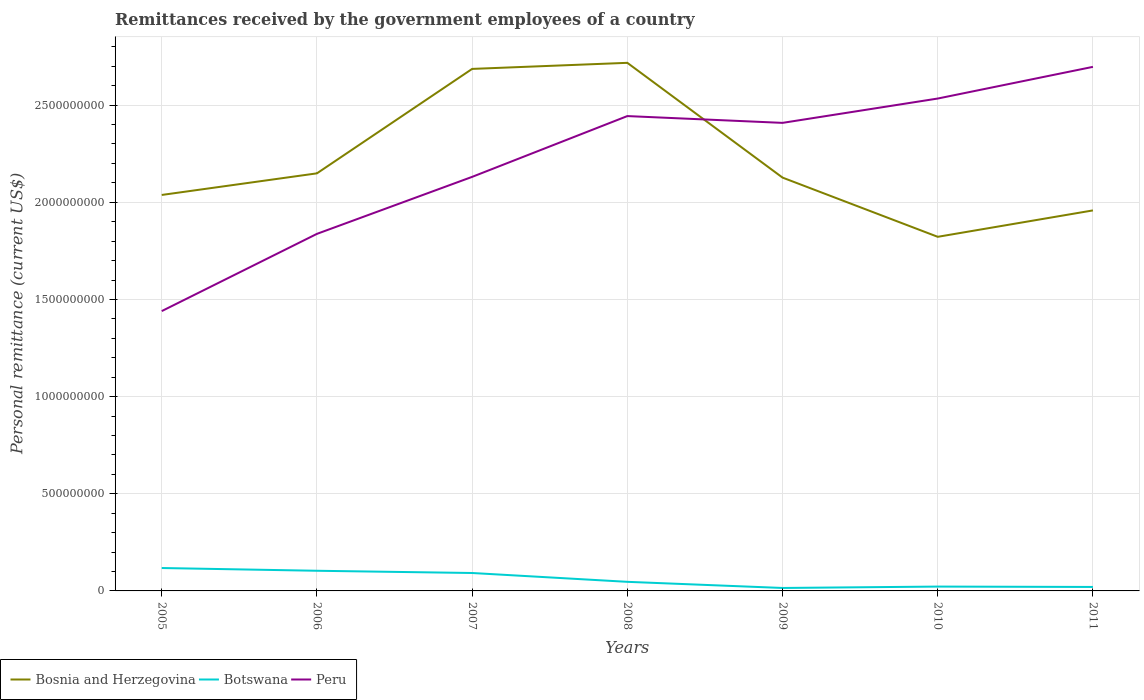How many different coloured lines are there?
Make the answer very short. 3. Across all years, what is the maximum remittances received by the government employees in Botswana?
Offer a terse response. 1.52e+07. In which year was the remittances received by the government employees in Bosnia and Herzegovina maximum?
Your answer should be very brief. 2010. What is the total remittances received by the government employees in Peru in the graph?
Your answer should be compact. -4.03e+08. What is the difference between the highest and the second highest remittances received by the government employees in Peru?
Provide a succinct answer. 1.26e+09. What is the difference between the highest and the lowest remittances received by the government employees in Botswana?
Your response must be concise. 3. How many lines are there?
Keep it short and to the point. 3. How many years are there in the graph?
Offer a very short reply. 7. Are the values on the major ticks of Y-axis written in scientific E-notation?
Provide a succinct answer. No. Does the graph contain grids?
Your response must be concise. Yes. Where does the legend appear in the graph?
Provide a succinct answer. Bottom left. How many legend labels are there?
Your answer should be compact. 3. How are the legend labels stacked?
Give a very brief answer. Horizontal. What is the title of the graph?
Offer a terse response. Remittances received by the government employees of a country. Does "Cuba" appear as one of the legend labels in the graph?
Your answer should be very brief. No. What is the label or title of the Y-axis?
Provide a short and direct response. Personal remittance (current US$). What is the Personal remittance (current US$) in Bosnia and Herzegovina in 2005?
Provide a short and direct response. 2.04e+09. What is the Personal remittance (current US$) of Botswana in 2005?
Offer a terse response. 1.18e+08. What is the Personal remittance (current US$) in Peru in 2005?
Make the answer very short. 1.44e+09. What is the Personal remittance (current US$) in Bosnia and Herzegovina in 2006?
Provide a short and direct response. 2.15e+09. What is the Personal remittance (current US$) of Botswana in 2006?
Keep it short and to the point. 1.04e+08. What is the Personal remittance (current US$) of Peru in 2006?
Your response must be concise. 1.84e+09. What is the Personal remittance (current US$) in Bosnia and Herzegovina in 2007?
Your answer should be compact. 2.69e+09. What is the Personal remittance (current US$) in Botswana in 2007?
Your answer should be very brief. 9.22e+07. What is the Personal remittance (current US$) in Peru in 2007?
Offer a terse response. 2.13e+09. What is the Personal remittance (current US$) of Bosnia and Herzegovina in 2008?
Provide a short and direct response. 2.72e+09. What is the Personal remittance (current US$) in Botswana in 2008?
Give a very brief answer. 4.68e+07. What is the Personal remittance (current US$) of Peru in 2008?
Ensure brevity in your answer.  2.44e+09. What is the Personal remittance (current US$) in Bosnia and Herzegovina in 2009?
Ensure brevity in your answer.  2.13e+09. What is the Personal remittance (current US$) in Botswana in 2009?
Provide a succinct answer. 1.52e+07. What is the Personal remittance (current US$) in Peru in 2009?
Give a very brief answer. 2.41e+09. What is the Personal remittance (current US$) in Bosnia and Herzegovina in 2010?
Your answer should be very brief. 1.82e+09. What is the Personal remittance (current US$) in Botswana in 2010?
Keep it short and to the point. 2.23e+07. What is the Personal remittance (current US$) in Peru in 2010?
Offer a terse response. 2.53e+09. What is the Personal remittance (current US$) of Bosnia and Herzegovina in 2011?
Your answer should be very brief. 1.96e+09. What is the Personal remittance (current US$) of Botswana in 2011?
Your answer should be very brief. 2.04e+07. What is the Personal remittance (current US$) in Peru in 2011?
Offer a very short reply. 2.70e+09. Across all years, what is the maximum Personal remittance (current US$) of Bosnia and Herzegovina?
Offer a terse response. 2.72e+09. Across all years, what is the maximum Personal remittance (current US$) in Botswana?
Your response must be concise. 1.18e+08. Across all years, what is the maximum Personal remittance (current US$) in Peru?
Provide a succinct answer. 2.70e+09. Across all years, what is the minimum Personal remittance (current US$) of Bosnia and Herzegovina?
Provide a short and direct response. 1.82e+09. Across all years, what is the minimum Personal remittance (current US$) in Botswana?
Provide a short and direct response. 1.52e+07. Across all years, what is the minimum Personal remittance (current US$) of Peru?
Your answer should be very brief. 1.44e+09. What is the total Personal remittance (current US$) in Bosnia and Herzegovina in the graph?
Make the answer very short. 1.55e+1. What is the total Personal remittance (current US$) in Botswana in the graph?
Ensure brevity in your answer.  4.19e+08. What is the total Personal remittance (current US$) of Peru in the graph?
Provide a succinct answer. 1.55e+1. What is the difference between the Personal remittance (current US$) of Bosnia and Herzegovina in 2005 and that in 2006?
Give a very brief answer. -1.11e+08. What is the difference between the Personal remittance (current US$) in Botswana in 2005 and that in 2006?
Ensure brevity in your answer.  1.41e+07. What is the difference between the Personal remittance (current US$) in Peru in 2005 and that in 2006?
Your answer should be very brief. -3.97e+08. What is the difference between the Personal remittance (current US$) of Bosnia and Herzegovina in 2005 and that in 2007?
Your answer should be very brief. -6.49e+08. What is the difference between the Personal remittance (current US$) in Botswana in 2005 and that in 2007?
Make the answer very short. 2.57e+07. What is the difference between the Personal remittance (current US$) of Peru in 2005 and that in 2007?
Offer a terse response. -6.91e+08. What is the difference between the Personal remittance (current US$) of Bosnia and Herzegovina in 2005 and that in 2008?
Provide a succinct answer. -6.80e+08. What is the difference between the Personal remittance (current US$) of Botswana in 2005 and that in 2008?
Your answer should be very brief. 7.11e+07. What is the difference between the Personal remittance (current US$) in Peru in 2005 and that in 2008?
Provide a short and direct response. -1.00e+09. What is the difference between the Personal remittance (current US$) of Bosnia and Herzegovina in 2005 and that in 2009?
Give a very brief answer. -8.93e+07. What is the difference between the Personal remittance (current US$) of Botswana in 2005 and that in 2009?
Your answer should be compact. 1.03e+08. What is the difference between the Personal remittance (current US$) of Peru in 2005 and that in 2009?
Make the answer very short. -9.69e+08. What is the difference between the Personal remittance (current US$) in Bosnia and Herzegovina in 2005 and that in 2010?
Your response must be concise. 2.15e+08. What is the difference between the Personal remittance (current US$) of Botswana in 2005 and that in 2010?
Provide a short and direct response. 9.56e+07. What is the difference between the Personal remittance (current US$) of Peru in 2005 and that in 2010?
Give a very brief answer. -1.09e+09. What is the difference between the Personal remittance (current US$) in Bosnia and Herzegovina in 2005 and that in 2011?
Keep it short and to the point. 7.95e+07. What is the difference between the Personal remittance (current US$) of Botswana in 2005 and that in 2011?
Give a very brief answer. 9.75e+07. What is the difference between the Personal remittance (current US$) in Peru in 2005 and that in 2011?
Offer a very short reply. -1.26e+09. What is the difference between the Personal remittance (current US$) in Bosnia and Herzegovina in 2006 and that in 2007?
Your response must be concise. -5.37e+08. What is the difference between the Personal remittance (current US$) in Botswana in 2006 and that in 2007?
Provide a short and direct response. 1.15e+07. What is the difference between the Personal remittance (current US$) of Peru in 2006 and that in 2007?
Your answer should be very brief. -2.93e+08. What is the difference between the Personal remittance (current US$) in Bosnia and Herzegovina in 2006 and that in 2008?
Provide a short and direct response. -5.69e+08. What is the difference between the Personal remittance (current US$) in Botswana in 2006 and that in 2008?
Give a very brief answer. 5.69e+07. What is the difference between the Personal remittance (current US$) of Peru in 2006 and that in 2008?
Keep it short and to the point. -6.06e+08. What is the difference between the Personal remittance (current US$) of Bosnia and Herzegovina in 2006 and that in 2009?
Keep it short and to the point. 2.19e+07. What is the difference between the Personal remittance (current US$) in Botswana in 2006 and that in 2009?
Keep it short and to the point. 8.85e+07. What is the difference between the Personal remittance (current US$) of Peru in 2006 and that in 2009?
Give a very brief answer. -5.71e+08. What is the difference between the Personal remittance (current US$) in Bosnia and Herzegovina in 2006 and that in 2010?
Your response must be concise. 3.27e+08. What is the difference between the Personal remittance (current US$) in Botswana in 2006 and that in 2010?
Ensure brevity in your answer.  8.14e+07. What is the difference between the Personal remittance (current US$) of Peru in 2006 and that in 2010?
Give a very brief answer. -6.96e+08. What is the difference between the Personal remittance (current US$) in Bosnia and Herzegovina in 2006 and that in 2011?
Offer a terse response. 1.91e+08. What is the difference between the Personal remittance (current US$) of Botswana in 2006 and that in 2011?
Your response must be concise. 8.33e+07. What is the difference between the Personal remittance (current US$) in Peru in 2006 and that in 2011?
Keep it short and to the point. -8.59e+08. What is the difference between the Personal remittance (current US$) of Bosnia and Herzegovina in 2007 and that in 2008?
Provide a succinct answer. -3.12e+07. What is the difference between the Personal remittance (current US$) in Botswana in 2007 and that in 2008?
Your answer should be very brief. 4.54e+07. What is the difference between the Personal remittance (current US$) in Peru in 2007 and that in 2008?
Keep it short and to the point. -3.13e+08. What is the difference between the Personal remittance (current US$) of Bosnia and Herzegovina in 2007 and that in 2009?
Give a very brief answer. 5.59e+08. What is the difference between the Personal remittance (current US$) in Botswana in 2007 and that in 2009?
Make the answer very short. 7.70e+07. What is the difference between the Personal remittance (current US$) in Peru in 2007 and that in 2009?
Provide a short and direct response. -2.78e+08. What is the difference between the Personal remittance (current US$) of Bosnia and Herzegovina in 2007 and that in 2010?
Your answer should be very brief. 8.64e+08. What is the difference between the Personal remittance (current US$) of Botswana in 2007 and that in 2010?
Offer a terse response. 6.99e+07. What is the difference between the Personal remittance (current US$) of Peru in 2007 and that in 2010?
Provide a succinct answer. -4.03e+08. What is the difference between the Personal remittance (current US$) of Bosnia and Herzegovina in 2007 and that in 2011?
Provide a short and direct response. 7.28e+08. What is the difference between the Personal remittance (current US$) of Botswana in 2007 and that in 2011?
Offer a very short reply. 7.18e+07. What is the difference between the Personal remittance (current US$) in Peru in 2007 and that in 2011?
Offer a very short reply. -5.66e+08. What is the difference between the Personal remittance (current US$) in Bosnia and Herzegovina in 2008 and that in 2009?
Keep it short and to the point. 5.91e+08. What is the difference between the Personal remittance (current US$) of Botswana in 2008 and that in 2009?
Give a very brief answer. 3.16e+07. What is the difference between the Personal remittance (current US$) of Peru in 2008 and that in 2009?
Ensure brevity in your answer.  3.49e+07. What is the difference between the Personal remittance (current US$) of Bosnia and Herzegovina in 2008 and that in 2010?
Keep it short and to the point. 8.95e+08. What is the difference between the Personal remittance (current US$) in Botswana in 2008 and that in 2010?
Ensure brevity in your answer.  2.45e+07. What is the difference between the Personal remittance (current US$) in Peru in 2008 and that in 2010?
Your answer should be very brief. -9.03e+07. What is the difference between the Personal remittance (current US$) of Bosnia and Herzegovina in 2008 and that in 2011?
Make the answer very short. 7.59e+08. What is the difference between the Personal remittance (current US$) in Botswana in 2008 and that in 2011?
Offer a very short reply. 2.64e+07. What is the difference between the Personal remittance (current US$) in Peru in 2008 and that in 2011?
Offer a terse response. -2.53e+08. What is the difference between the Personal remittance (current US$) in Bosnia and Herzegovina in 2009 and that in 2010?
Your answer should be compact. 3.05e+08. What is the difference between the Personal remittance (current US$) in Botswana in 2009 and that in 2010?
Provide a succinct answer. -7.11e+06. What is the difference between the Personal remittance (current US$) in Peru in 2009 and that in 2010?
Provide a succinct answer. -1.25e+08. What is the difference between the Personal remittance (current US$) of Bosnia and Herzegovina in 2009 and that in 2011?
Ensure brevity in your answer.  1.69e+08. What is the difference between the Personal remittance (current US$) of Botswana in 2009 and that in 2011?
Ensure brevity in your answer.  -5.23e+06. What is the difference between the Personal remittance (current US$) in Peru in 2009 and that in 2011?
Your response must be concise. -2.88e+08. What is the difference between the Personal remittance (current US$) of Bosnia and Herzegovina in 2010 and that in 2011?
Give a very brief answer. -1.36e+08. What is the difference between the Personal remittance (current US$) in Botswana in 2010 and that in 2011?
Ensure brevity in your answer.  1.88e+06. What is the difference between the Personal remittance (current US$) in Peru in 2010 and that in 2011?
Your response must be concise. -1.63e+08. What is the difference between the Personal remittance (current US$) in Bosnia and Herzegovina in 2005 and the Personal remittance (current US$) in Botswana in 2006?
Your answer should be compact. 1.93e+09. What is the difference between the Personal remittance (current US$) of Bosnia and Herzegovina in 2005 and the Personal remittance (current US$) of Peru in 2006?
Provide a succinct answer. 2.00e+08. What is the difference between the Personal remittance (current US$) of Botswana in 2005 and the Personal remittance (current US$) of Peru in 2006?
Make the answer very short. -1.72e+09. What is the difference between the Personal remittance (current US$) in Bosnia and Herzegovina in 2005 and the Personal remittance (current US$) in Botswana in 2007?
Offer a very short reply. 1.95e+09. What is the difference between the Personal remittance (current US$) in Bosnia and Herzegovina in 2005 and the Personal remittance (current US$) in Peru in 2007?
Provide a short and direct response. -9.31e+07. What is the difference between the Personal remittance (current US$) of Botswana in 2005 and the Personal remittance (current US$) of Peru in 2007?
Your response must be concise. -2.01e+09. What is the difference between the Personal remittance (current US$) in Bosnia and Herzegovina in 2005 and the Personal remittance (current US$) in Botswana in 2008?
Offer a very short reply. 1.99e+09. What is the difference between the Personal remittance (current US$) in Bosnia and Herzegovina in 2005 and the Personal remittance (current US$) in Peru in 2008?
Your response must be concise. -4.06e+08. What is the difference between the Personal remittance (current US$) in Botswana in 2005 and the Personal remittance (current US$) in Peru in 2008?
Give a very brief answer. -2.33e+09. What is the difference between the Personal remittance (current US$) of Bosnia and Herzegovina in 2005 and the Personal remittance (current US$) of Botswana in 2009?
Your answer should be compact. 2.02e+09. What is the difference between the Personal remittance (current US$) of Bosnia and Herzegovina in 2005 and the Personal remittance (current US$) of Peru in 2009?
Provide a short and direct response. -3.71e+08. What is the difference between the Personal remittance (current US$) of Botswana in 2005 and the Personal remittance (current US$) of Peru in 2009?
Provide a succinct answer. -2.29e+09. What is the difference between the Personal remittance (current US$) of Bosnia and Herzegovina in 2005 and the Personal remittance (current US$) of Botswana in 2010?
Provide a short and direct response. 2.02e+09. What is the difference between the Personal remittance (current US$) in Bosnia and Herzegovina in 2005 and the Personal remittance (current US$) in Peru in 2010?
Keep it short and to the point. -4.96e+08. What is the difference between the Personal remittance (current US$) of Botswana in 2005 and the Personal remittance (current US$) of Peru in 2010?
Your response must be concise. -2.42e+09. What is the difference between the Personal remittance (current US$) of Bosnia and Herzegovina in 2005 and the Personal remittance (current US$) of Botswana in 2011?
Offer a very short reply. 2.02e+09. What is the difference between the Personal remittance (current US$) of Bosnia and Herzegovina in 2005 and the Personal remittance (current US$) of Peru in 2011?
Your response must be concise. -6.59e+08. What is the difference between the Personal remittance (current US$) of Botswana in 2005 and the Personal remittance (current US$) of Peru in 2011?
Offer a terse response. -2.58e+09. What is the difference between the Personal remittance (current US$) in Bosnia and Herzegovina in 2006 and the Personal remittance (current US$) in Botswana in 2007?
Your answer should be compact. 2.06e+09. What is the difference between the Personal remittance (current US$) in Bosnia and Herzegovina in 2006 and the Personal remittance (current US$) in Peru in 2007?
Make the answer very short. 1.81e+07. What is the difference between the Personal remittance (current US$) in Botswana in 2006 and the Personal remittance (current US$) in Peru in 2007?
Your response must be concise. -2.03e+09. What is the difference between the Personal remittance (current US$) in Bosnia and Herzegovina in 2006 and the Personal remittance (current US$) in Botswana in 2008?
Provide a succinct answer. 2.10e+09. What is the difference between the Personal remittance (current US$) in Bosnia and Herzegovina in 2006 and the Personal remittance (current US$) in Peru in 2008?
Offer a terse response. -2.95e+08. What is the difference between the Personal remittance (current US$) in Botswana in 2006 and the Personal remittance (current US$) in Peru in 2008?
Your answer should be very brief. -2.34e+09. What is the difference between the Personal remittance (current US$) of Bosnia and Herzegovina in 2006 and the Personal remittance (current US$) of Botswana in 2009?
Your response must be concise. 2.13e+09. What is the difference between the Personal remittance (current US$) in Bosnia and Herzegovina in 2006 and the Personal remittance (current US$) in Peru in 2009?
Your response must be concise. -2.60e+08. What is the difference between the Personal remittance (current US$) of Botswana in 2006 and the Personal remittance (current US$) of Peru in 2009?
Offer a very short reply. -2.30e+09. What is the difference between the Personal remittance (current US$) in Bosnia and Herzegovina in 2006 and the Personal remittance (current US$) in Botswana in 2010?
Provide a short and direct response. 2.13e+09. What is the difference between the Personal remittance (current US$) of Bosnia and Herzegovina in 2006 and the Personal remittance (current US$) of Peru in 2010?
Provide a short and direct response. -3.85e+08. What is the difference between the Personal remittance (current US$) of Botswana in 2006 and the Personal remittance (current US$) of Peru in 2010?
Make the answer very short. -2.43e+09. What is the difference between the Personal remittance (current US$) of Bosnia and Herzegovina in 2006 and the Personal remittance (current US$) of Botswana in 2011?
Ensure brevity in your answer.  2.13e+09. What is the difference between the Personal remittance (current US$) of Bosnia and Herzegovina in 2006 and the Personal remittance (current US$) of Peru in 2011?
Provide a succinct answer. -5.48e+08. What is the difference between the Personal remittance (current US$) in Botswana in 2006 and the Personal remittance (current US$) in Peru in 2011?
Offer a very short reply. -2.59e+09. What is the difference between the Personal remittance (current US$) of Bosnia and Herzegovina in 2007 and the Personal remittance (current US$) of Botswana in 2008?
Your response must be concise. 2.64e+09. What is the difference between the Personal remittance (current US$) in Bosnia and Herzegovina in 2007 and the Personal remittance (current US$) in Peru in 2008?
Make the answer very short. 2.43e+08. What is the difference between the Personal remittance (current US$) of Botswana in 2007 and the Personal remittance (current US$) of Peru in 2008?
Your response must be concise. -2.35e+09. What is the difference between the Personal remittance (current US$) in Bosnia and Herzegovina in 2007 and the Personal remittance (current US$) in Botswana in 2009?
Offer a terse response. 2.67e+09. What is the difference between the Personal remittance (current US$) in Bosnia and Herzegovina in 2007 and the Personal remittance (current US$) in Peru in 2009?
Offer a terse response. 2.78e+08. What is the difference between the Personal remittance (current US$) in Botswana in 2007 and the Personal remittance (current US$) in Peru in 2009?
Your answer should be compact. -2.32e+09. What is the difference between the Personal remittance (current US$) in Bosnia and Herzegovina in 2007 and the Personal remittance (current US$) in Botswana in 2010?
Keep it short and to the point. 2.66e+09. What is the difference between the Personal remittance (current US$) of Bosnia and Herzegovina in 2007 and the Personal remittance (current US$) of Peru in 2010?
Give a very brief answer. 1.53e+08. What is the difference between the Personal remittance (current US$) in Botswana in 2007 and the Personal remittance (current US$) in Peru in 2010?
Your answer should be very brief. -2.44e+09. What is the difference between the Personal remittance (current US$) in Bosnia and Herzegovina in 2007 and the Personal remittance (current US$) in Botswana in 2011?
Your response must be concise. 2.67e+09. What is the difference between the Personal remittance (current US$) in Bosnia and Herzegovina in 2007 and the Personal remittance (current US$) in Peru in 2011?
Your answer should be very brief. -1.05e+07. What is the difference between the Personal remittance (current US$) of Botswana in 2007 and the Personal remittance (current US$) of Peru in 2011?
Your answer should be very brief. -2.60e+09. What is the difference between the Personal remittance (current US$) in Bosnia and Herzegovina in 2008 and the Personal remittance (current US$) in Botswana in 2009?
Your answer should be compact. 2.70e+09. What is the difference between the Personal remittance (current US$) of Bosnia and Herzegovina in 2008 and the Personal remittance (current US$) of Peru in 2009?
Make the answer very short. 3.09e+08. What is the difference between the Personal remittance (current US$) in Botswana in 2008 and the Personal remittance (current US$) in Peru in 2009?
Provide a short and direct response. -2.36e+09. What is the difference between the Personal remittance (current US$) of Bosnia and Herzegovina in 2008 and the Personal remittance (current US$) of Botswana in 2010?
Your answer should be very brief. 2.70e+09. What is the difference between the Personal remittance (current US$) in Bosnia and Herzegovina in 2008 and the Personal remittance (current US$) in Peru in 2010?
Your answer should be very brief. 1.84e+08. What is the difference between the Personal remittance (current US$) in Botswana in 2008 and the Personal remittance (current US$) in Peru in 2010?
Offer a terse response. -2.49e+09. What is the difference between the Personal remittance (current US$) of Bosnia and Herzegovina in 2008 and the Personal remittance (current US$) of Botswana in 2011?
Keep it short and to the point. 2.70e+09. What is the difference between the Personal remittance (current US$) in Bosnia and Herzegovina in 2008 and the Personal remittance (current US$) in Peru in 2011?
Keep it short and to the point. 2.07e+07. What is the difference between the Personal remittance (current US$) of Botswana in 2008 and the Personal remittance (current US$) of Peru in 2011?
Give a very brief answer. -2.65e+09. What is the difference between the Personal remittance (current US$) of Bosnia and Herzegovina in 2009 and the Personal remittance (current US$) of Botswana in 2010?
Provide a short and direct response. 2.10e+09. What is the difference between the Personal remittance (current US$) of Bosnia and Herzegovina in 2009 and the Personal remittance (current US$) of Peru in 2010?
Provide a succinct answer. -4.07e+08. What is the difference between the Personal remittance (current US$) of Botswana in 2009 and the Personal remittance (current US$) of Peru in 2010?
Keep it short and to the point. -2.52e+09. What is the difference between the Personal remittance (current US$) of Bosnia and Herzegovina in 2009 and the Personal remittance (current US$) of Botswana in 2011?
Give a very brief answer. 2.11e+09. What is the difference between the Personal remittance (current US$) of Bosnia and Herzegovina in 2009 and the Personal remittance (current US$) of Peru in 2011?
Offer a very short reply. -5.70e+08. What is the difference between the Personal remittance (current US$) in Botswana in 2009 and the Personal remittance (current US$) in Peru in 2011?
Give a very brief answer. -2.68e+09. What is the difference between the Personal remittance (current US$) of Bosnia and Herzegovina in 2010 and the Personal remittance (current US$) of Botswana in 2011?
Give a very brief answer. 1.80e+09. What is the difference between the Personal remittance (current US$) of Bosnia and Herzegovina in 2010 and the Personal remittance (current US$) of Peru in 2011?
Offer a terse response. -8.75e+08. What is the difference between the Personal remittance (current US$) of Botswana in 2010 and the Personal remittance (current US$) of Peru in 2011?
Make the answer very short. -2.67e+09. What is the average Personal remittance (current US$) of Bosnia and Herzegovina per year?
Keep it short and to the point. 2.21e+09. What is the average Personal remittance (current US$) of Botswana per year?
Provide a short and direct response. 5.98e+07. What is the average Personal remittance (current US$) of Peru per year?
Offer a very short reply. 2.21e+09. In the year 2005, what is the difference between the Personal remittance (current US$) in Bosnia and Herzegovina and Personal remittance (current US$) in Botswana?
Provide a succinct answer. 1.92e+09. In the year 2005, what is the difference between the Personal remittance (current US$) in Bosnia and Herzegovina and Personal remittance (current US$) in Peru?
Your response must be concise. 5.98e+08. In the year 2005, what is the difference between the Personal remittance (current US$) in Botswana and Personal remittance (current US$) in Peru?
Provide a short and direct response. -1.32e+09. In the year 2006, what is the difference between the Personal remittance (current US$) in Bosnia and Herzegovina and Personal remittance (current US$) in Botswana?
Offer a very short reply. 2.05e+09. In the year 2006, what is the difference between the Personal remittance (current US$) in Bosnia and Herzegovina and Personal remittance (current US$) in Peru?
Keep it short and to the point. 3.11e+08. In the year 2006, what is the difference between the Personal remittance (current US$) of Botswana and Personal remittance (current US$) of Peru?
Provide a short and direct response. -1.73e+09. In the year 2007, what is the difference between the Personal remittance (current US$) of Bosnia and Herzegovina and Personal remittance (current US$) of Botswana?
Provide a succinct answer. 2.59e+09. In the year 2007, what is the difference between the Personal remittance (current US$) in Bosnia and Herzegovina and Personal remittance (current US$) in Peru?
Provide a succinct answer. 5.56e+08. In the year 2007, what is the difference between the Personal remittance (current US$) in Botswana and Personal remittance (current US$) in Peru?
Your answer should be compact. -2.04e+09. In the year 2008, what is the difference between the Personal remittance (current US$) of Bosnia and Herzegovina and Personal remittance (current US$) of Botswana?
Your response must be concise. 2.67e+09. In the year 2008, what is the difference between the Personal remittance (current US$) of Bosnia and Herzegovina and Personal remittance (current US$) of Peru?
Ensure brevity in your answer.  2.74e+08. In the year 2008, what is the difference between the Personal remittance (current US$) of Botswana and Personal remittance (current US$) of Peru?
Offer a terse response. -2.40e+09. In the year 2009, what is the difference between the Personal remittance (current US$) of Bosnia and Herzegovina and Personal remittance (current US$) of Botswana?
Keep it short and to the point. 2.11e+09. In the year 2009, what is the difference between the Personal remittance (current US$) in Bosnia and Herzegovina and Personal remittance (current US$) in Peru?
Offer a terse response. -2.82e+08. In the year 2009, what is the difference between the Personal remittance (current US$) in Botswana and Personal remittance (current US$) in Peru?
Provide a short and direct response. -2.39e+09. In the year 2010, what is the difference between the Personal remittance (current US$) in Bosnia and Herzegovina and Personal remittance (current US$) in Botswana?
Your response must be concise. 1.80e+09. In the year 2010, what is the difference between the Personal remittance (current US$) in Bosnia and Herzegovina and Personal remittance (current US$) in Peru?
Ensure brevity in your answer.  -7.12e+08. In the year 2010, what is the difference between the Personal remittance (current US$) of Botswana and Personal remittance (current US$) of Peru?
Keep it short and to the point. -2.51e+09. In the year 2011, what is the difference between the Personal remittance (current US$) of Bosnia and Herzegovina and Personal remittance (current US$) of Botswana?
Your answer should be very brief. 1.94e+09. In the year 2011, what is the difference between the Personal remittance (current US$) in Bosnia and Herzegovina and Personal remittance (current US$) in Peru?
Your answer should be very brief. -7.39e+08. In the year 2011, what is the difference between the Personal remittance (current US$) of Botswana and Personal remittance (current US$) of Peru?
Keep it short and to the point. -2.68e+09. What is the ratio of the Personal remittance (current US$) of Bosnia and Herzegovina in 2005 to that in 2006?
Offer a terse response. 0.95. What is the ratio of the Personal remittance (current US$) of Botswana in 2005 to that in 2006?
Make the answer very short. 1.14. What is the ratio of the Personal remittance (current US$) in Peru in 2005 to that in 2006?
Your answer should be very brief. 0.78. What is the ratio of the Personal remittance (current US$) of Bosnia and Herzegovina in 2005 to that in 2007?
Your answer should be very brief. 0.76. What is the ratio of the Personal remittance (current US$) in Botswana in 2005 to that in 2007?
Give a very brief answer. 1.28. What is the ratio of the Personal remittance (current US$) of Peru in 2005 to that in 2007?
Ensure brevity in your answer.  0.68. What is the ratio of the Personal remittance (current US$) of Bosnia and Herzegovina in 2005 to that in 2008?
Keep it short and to the point. 0.75. What is the ratio of the Personal remittance (current US$) in Botswana in 2005 to that in 2008?
Provide a short and direct response. 2.52. What is the ratio of the Personal remittance (current US$) in Peru in 2005 to that in 2008?
Offer a terse response. 0.59. What is the ratio of the Personal remittance (current US$) in Bosnia and Herzegovina in 2005 to that in 2009?
Make the answer very short. 0.96. What is the ratio of the Personal remittance (current US$) in Botswana in 2005 to that in 2009?
Offer a very short reply. 7.75. What is the ratio of the Personal remittance (current US$) in Peru in 2005 to that in 2009?
Make the answer very short. 0.6. What is the ratio of the Personal remittance (current US$) in Bosnia and Herzegovina in 2005 to that in 2010?
Your answer should be very brief. 1.12. What is the ratio of the Personal remittance (current US$) in Botswana in 2005 to that in 2010?
Provide a short and direct response. 5.28. What is the ratio of the Personal remittance (current US$) of Peru in 2005 to that in 2010?
Give a very brief answer. 0.57. What is the ratio of the Personal remittance (current US$) of Bosnia and Herzegovina in 2005 to that in 2011?
Offer a very short reply. 1.04. What is the ratio of the Personal remittance (current US$) in Botswana in 2005 to that in 2011?
Offer a terse response. 5.77. What is the ratio of the Personal remittance (current US$) in Peru in 2005 to that in 2011?
Your response must be concise. 0.53. What is the ratio of the Personal remittance (current US$) in Bosnia and Herzegovina in 2006 to that in 2007?
Your answer should be very brief. 0.8. What is the ratio of the Personal remittance (current US$) in Botswana in 2006 to that in 2007?
Your response must be concise. 1.13. What is the ratio of the Personal remittance (current US$) in Peru in 2006 to that in 2007?
Ensure brevity in your answer.  0.86. What is the ratio of the Personal remittance (current US$) in Bosnia and Herzegovina in 2006 to that in 2008?
Provide a succinct answer. 0.79. What is the ratio of the Personal remittance (current US$) of Botswana in 2006 to that in 2008?
Ensure brevity in your answer.  2.22. What is the ratio of the Personal remittance (current US$) of Peru in 2006 to that in 2008?
Keep it short and to the point. 0.75. What is the ratio of the Personal remittance (current US$) of Bosnia and Herzegovina in 2006 to that in 2009?
Provide a short and direct response. 1.01. What is the ratio of the Personal remittance (current US$) in Botswana in 2006 to that in 2009?
Your answer should be very brief. 6.82. What is the ratio of the Personal remittance (current US$) of Peru in 2006 to that in 2009?
Offer a very short reply. 0.76. What is the ratio of the Personal remittance (current US$) of Bosnia and Herzegovina in 2006 to that in 2010?
Your answer should be very brief. 1.18. What is the ratio of the Personal remittance (current US$) in Botswana in 2006 to that in 2010?
Provide a succinct answer. 4.65. What is the ratio of the Personal remittance (current US$) in Peru in 2006 to that in 2010?
Your response must be concise. 0.73. What is the ratio of the Personal remittance (current US$) in Bosnia and Herzegovina in 2006 to that in 2011?
Offer a very short reply. 1.1. What is the ratio of the Personal remittance (current US$) of Botswana in 2006 to that in 2011?
Your answer should be very brief. 5.08. What is the ratio of the Personal remittance (current US$) of Peru in 2006 to that in 2011?
Provide a succinct answer. 0.68. What is the ratio of the Personal remittance (current US$) in Bosnia and Herzegovina in 2007 to that in 2008?
Ensure brevity in your answer.  0.99. What is the ratio of the Personal remittance (current US$) of Botswana in 2007 to that in 2008?
Keep it short and to the point. 1.97. What is the ratio of the Personal remittance (current US$) of Peru in 2007 to that in 2008?
Your answer should be very brief. 0.87. What is the ratio of the Personal remittance (current US$) of Bosnia and Herzegovina in 2007 to that in 2009?
Offer a very short reply. 1.26. What is the ratio of the Personal remittance (current US$) in Botswana in 2007 to that in 2009?
Ensure brevity in your answer.  6.06. What is the ratio of the Personal remittance (current US$) of Peru in 2007 to that in 2009?
Offer a very short reply. 0.88. What is the ratio of the Personal remittance (current US$) of Bosnia and Herzegovina in 2007 to that in 2010?
Your answer should be compact. 1.47. What is the ratio of the Personal remittance (current US$) of Botswana in 2007 to that in 2010?
Ensure brevity in your answer.  4.13. What is the ratio of the Personal remittance (current US$) in Peru in 2007 to that in 2010?
Your answer should be very brief. 0.84. What is the ratio of the Personal remittance (current US$) of Bosnia and Herzegovina in 2007 to that in 2011?
Give a very brief answer. 1.37. What is the ratio of the Personal remittance (current US$) in Botswana in 2007 to that in 2011?
Your answer should be compact. 4.51. What is the ratio of the Personal remittance (current US$) in Peru in 2007 to that in 2011?
Provide a short and direct response. 0.79. What is the ratio of the Personal remittance (current US$) of Bosnia and Herzegovina in 2008 to that in 2009?
Keep it short and to the point. 1.28. What is the ratio of the Personal remittance (current US$) in Botswana in 2008 to that in 2009?
Your response must be concise. 3.08. What is the ratio of the Personal remittance (current US$) of Peru in 2008 to that in 2009?
Keep it short and to the point. 1.01. What is the ratio of the Personal remittance (current US$) of Bosnia and Herzegovina in 2008 to that in 2010?
Your answer should be very brief. 1.49. What is the ratio of the Personal remittance (current US$) in Botswana in 2008 to that in 2010?
Ensure brevity in your answer.  2.1. What is the ratio of the Personal remittance (current US$) in Peru in 2008 to that in 2010?
Offer a very short reply. 0.96. What is the ratio of the Personal remittance (current US$) in Bosnia and Herzegovina in 2008 to that in 2011?
Make the answer very short. 1.39. What is the ratio of the Personal remittance (current US$) of Botswana in 2008 to that in 2011?
Provide a short and direct response. 2.29. What is the ratio of the Personal remittance (current US$) of Peru in 2008 to that in 2011?
Your answer should be compact. 0.91. What is the ratio of the Personal remittance (current US$) of Bosnia and Herzegovina in 2009 to that in 2010?
Your response must be concise. 1.17. What is the ratio of the Personal remittance (current US$) in Botswana in 2009 to that in 2010?
Give a very brief answer. 0.68. What is the ratio of the Personal remittance (current US$) in Peru in 2009 to that in 2010?
Provide a short and direct response. 0.95. What is the ratio of the Personal remittance (current US$) of Bosnia and Herzegovina in 2009 to that in 2011?
Your answer should be compact. 1.09. What is the ratio of the Personal remittance (current US$) in Botswana in 2009 to that in 2011?
Make the answer very short. 0.74. What is the ratio of the Personal remittance (current US$) of Peru in 2009 to that in 2011?
Offer a terse response. 0.89. What is the ratio of the Personal remittance (current US$) of Bosnia and Herzegovina in 2010 to that in 2011?
Offer a very short reply. 0.93. What is the ratio of the Personal remittance (current US$) in Botswana in 2010 to that in 2011?
Your answer should be very brief. 1.09. What is the ratio of the Personal remittance (current US$) in Peru in 2010 to that in 2011?
Provide a short and direct response. 0.94. What is the difference between the highest and the second highest Personal remittance (current US$) in Bosnia and Herzegovina?
Your answer should be compact. 3.12e+07. What is the difference between the highest and the second highest Personal remittance (current US$) in Botswana?
Give a very brief answer. 1.41e+07. What is the difference between the highest and the second highest Personal remittance (current US$) of Peru?
Provide a short and direct response. 1.63e+08. What is the difference between the highest and the lowest Personal remittance (current US$) in Bosnia and Herzegovina?
Keep it short and to the point. 8.95e+08. What is the difference between the highest and the lowest Personal remittance (current US$) in Botswana?
Your answer should be very brief. 1.03e+08. What is the difference between the highest and the lowest Personal remittance (current US$) in Peru?
Give a very brief answer. 1.26e+09. 